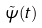Convert formula to latex. <formula><loc_0><loc_0><loc_500><loc_500>\tilde { \psi } ( t )</formula> 